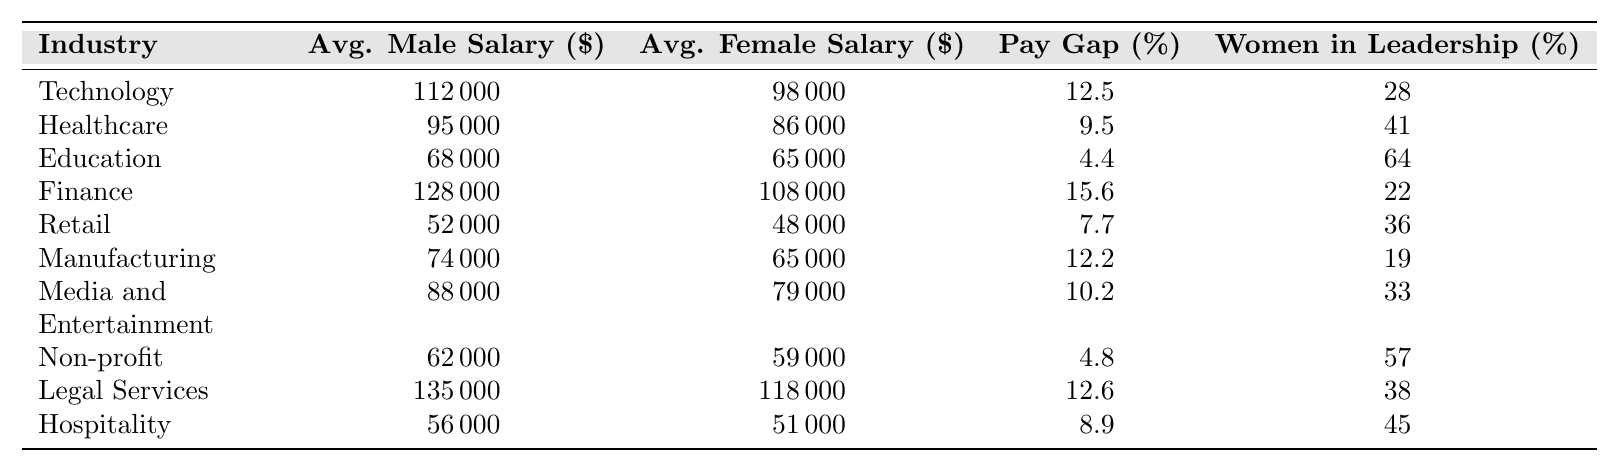What is the average male salary in the Technology industry? From the table, the average male salary in the Technology industry is listed as $112,000.
Answer: $112,000 What is the pay gap percentage in Healthcare? The pay gap percentage for the Healthcare industry is given in the table as 9.5%.
Answer: 9.5% Which industry has the highest average male salary? By examining the table, the Finance industry has the highest average male salary at $128,000.
Answer: Finance What is the average female salary in Education? The table shows that the average female salary in the Education industry is $65,000.
Answer: $65,000 What percentage of women are in leadership positions in the Manufacturing industry? According to the table, the percentage of women in leadership positions in the Manufacturing industry is 19%.
Answer: 19% Is the pay gap in the legal services industry greater than 10%? The pay gap in the Legal Services industry is 12.6%, which is greater than 10%.
Answer: Yes What is the difference between the average male salary and the average female salary in Retail? The average male salary in Retail is $52,000, and the average female salary is $48,000. The difference is $52,000 - $48,000 = $4,000.
Answer: $4,000 How does the pay gap in the Media and Entertainment industry compare to the pay gap in the Hospitality industry? The pay gap in Media and Entertainment is 10.2%, while the pay gap in Hospitality is 8.9%. Since 10.2% is greater than 8.9%, Media and Entertainment has a higher pay gap.
Answer: Higher in Media and Entertainment What is the average of the average male salaries for all industries listed? The average male salaries are: 112000, 95000, 68000, 128000, 52000, 74000, 88000, 62000, 135000, 56000. Summing these gives 844000, and dividing by 10 gives the average $84,400.
Answer: $84,400 In which industry is the percentage of women in leadership the highest? The table indicates that Education has the highest percentage of women in leadership at 64%.
Answer: Education What is the average pay gap across all industries? The pay gaps are: 12.5, 9.5, 4.4, 15.6, 7.7, 12.2, 10.2, 4.8, 12.6, 8.9. Adding these gives a total of 5, that's 5 + 10 = 15, and dividing gives an average of 10.44%.
Answer: 10.44% 